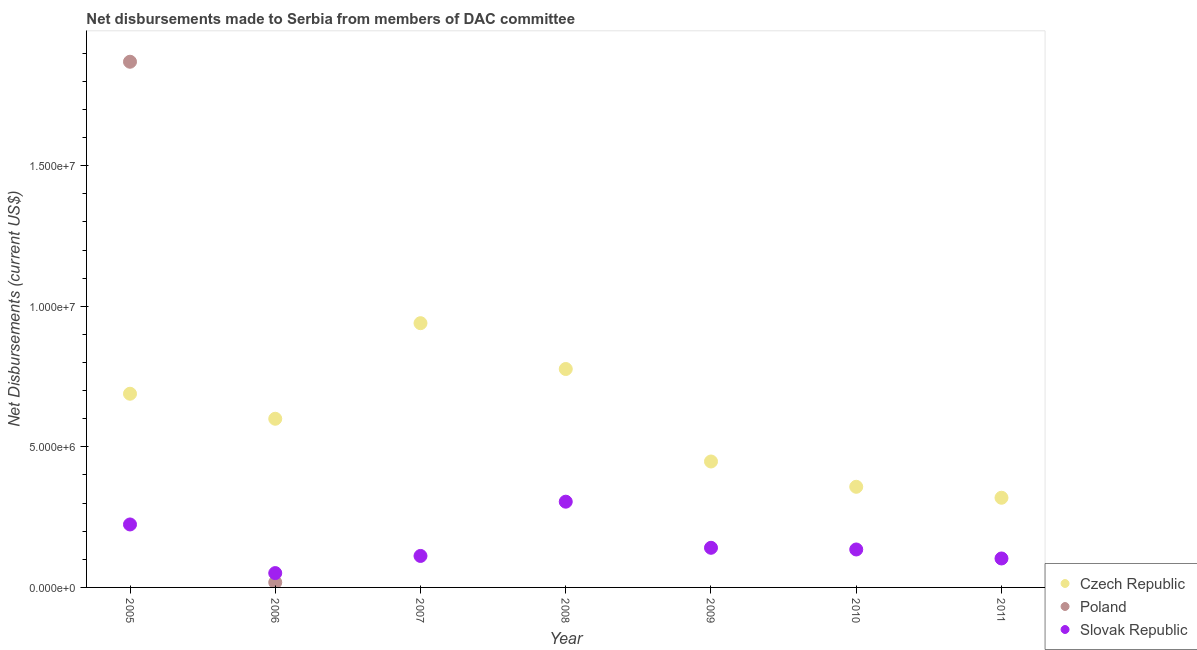How many different coloured dotlines are there?
Your response must be concise. 3. What is the net disbursements made by slovak republic in 2010?
Keep it short and to the point. 1.35e+06. Across all years, what is the maximum net disbursements made by slovak republic?
Provide a succinct answer. 3.05e+06. Across all years, what is the minimum net disbursements made by slovak republic?
Provide a succinct answer. 5.10e+05. In which year was the net disbursements made by poland maximum?
Provide a short and direct response. 2005. What is the total net disbursements made by czech republic in the graph?
Provide a short and direct response. 4.13e+07. What is the difference between the net disbursements made by czech republic in 2007 and that in 2010?
Offer a terse response. 5.82e+06. What is the difference between the net disbursements made by slovak republic in 2011 and the net disbursements made by czech republic in 2010?
Make the answer very short. -2.55e+06. What is the average net disbursements made by czech republic per year?
Give a very brief answer. 5.90e+06. In the year 2006, what is the difference between the net disbursements made by slovak republic and net disbursements made by czech republic?
Your answer should be very brief. -5.49e+06. What is the ratio of the net disbursements made by slovak republic in 2007 to that in 2010?
Give a very brief answer. 0.83. Is the net disbursements made by slovak republic in 2008 less than that in 2011?
Your answer should be very brief. No. What is the difference between the highest and the second highest net disbursements made by czech republic?
Offer a terse response. 1.63e+06. What is the difference between the highest and the lowest net disbursements made by poland?
Offer a terse response. 1.87e+07. Is it the case that in every year, the sum of the net disbursements made by czech republic and net disbursements made by poland is greater than the net disbursements made by slovak republic?
Make the answer very short. Yes. Does the net disbursements made by czech republic monotonically increase over the years?
Offer a very short reply. No. Is the net disbursements made by czech republic strictly greater than the net disbursements made by poland over the years?
Your response must be concise. No. Is the net disbursements made by slovak republic strictly less than the net disbursements made by poland over the years?
Keep it short and to the point. No. How many years are there in the graph?
Ensure brevity in your answer.  7. Are the values on the major ticks of Y-axis written in scientific E-notation?
Your answer should be very brief. Yes. Does the graph contain grids?
Make the answer very short. No. What is the title of the graph?
Make the answer very short. Net disbursements made to Serbia from members of DAC committee. Does "Ages 20-60" appear as one of the legend labels in the graph?
Keep it short and to the point. No. What is the label or title of the X-axis?
Provide a short and direct response. Year. What is the label or title of the Y-axis?
Provide a short and direct response. Net Disbursements (current US$). What is the Net Disbursements (current US$) in Czech Republic in 2005?
Ensure brevity in your answer.  6.89e+06. What is the Net Disbursements (current US$) in Poland in 2005?
Give a very brief answer. 1.87e+07. What is the Net Disbursements (current US$) of Slovak Republic in 2005?
Offer a terse response. 2.24e+06. What is the Net Disbursements (current US$) of Poland in 2006?
Give a very brief answer. 1.80e+05. What is the Net Disbursements (current US$) of Slovak Republic in 2006?
Keep it short and to the point. 5.10e+05. What is the Net Disbursements (current US$) of Czech Republic in 2007?
Make the answer very short. 9.40e+06. What is the Net Disbursements (current US$) of Slovak Republic in 2007?
Your answer should be compact. 1.12e+06. What is the Net Disbursements (current US$) in Czech Republic in 2008?
Give a very brief answer. 7.77e+06. What is the Net Disbursements (current US$) in Poland in 2008?
Make the answer very short. 0. What is the Net Disbursements (current US$) in Slovak Republic in 2008?
Give a very brief answer. 3.05e+06. What is the Net Disbursements (current US$) of Czech Republic in 2009?
Provide a short and direct response. 4.48e+06. What is the Net Disbursements (current US$) of Slovak Republic in 2009?
Ensure brevity in your answer.  1.41e+06. What is the Net Disbursements (current US$) of Czech Republic in 2010?
Offer a terse response. 3.58e+06. What is the Net Disbursements (current US$) of Poland in 2010?
Ensure brevity in your answer.  0. What is the Net Disbursements (current US$) of Slovak Republic in 2010?
Provide a succinct answer. 1.35e+06. What is the Net Disbursements (current US$) of Czech Republic in 2011?
Keep it short and to the point. 3.19e+06. What is the Net Disbursements (current US$) of Slovak Republic in 2011?
Offer a terse response. 1.03e+06. Across all years, what is the maximum Net Disbursements (current US$) of Czech Republic?
Ensure brevity in your answer.  9.40e+06. Across all years, what is the maximum Net Disbursements (current US$) of Poland?
Your answer should be compact. 1.87e+07. Across all years, what is the maximum Net Disbursements (current US$) of Slovak Republic?
Provide a short and direct response. 3.05e+06. Across all years, what is the minimum Net Disbursements (current US$) in Czech Republic?
Offer a very short reply. 3.19e+06. Across all years, what is the minimum Net Disbursements (current US$) of Poland?
Your response must be concise. 0. Across all years, what is the minimum Net Disbursements (current US$) in Slovak Republic?
Give a very brief answer. 5.10e+05. What is the total Net Disbursements (current US$) in Czech Republic in the graph?
Ensure brevity in your answer.  4.13e+07. What is the total Net Disbursements (current US$) in Poland in the graph?
Your answer should be very brief. 1.89e+07. What is the total Net Disbursements (current US$) in Slovak Republic in the graph?
Offer a very short reply. 1.07e+07. What is the difference between the Net Disbursements (current US$) of Czech Republic in 2005 and that in 2006?
Your response must be concise. 8.90e+05. What is the difference between the Net Disbursements (current US$) of Poland in 2005 and that in 2006?
Keep it short and to the point. 1.85e+07. What is the difference between the Net Disbursements (current US$) in Slovak Republic in 2005 and that in 2006?
Provide a succinct answer. 1.73e+06. What is the difference between the Net Disbursements (current US$) of Czech Republic in 2005 and that in 2007?
Keep it short and to the point. -2.51e+06. What is the difference between the Net Disbursements (current US$) in Slovak Republic in 2005 and that in 2007?
Your response must be concise. 1.12e+06. What is the difference between the Net Disbursements (current US$) in Czech Republic in 2005 and that in 2008?
Keep it short and to the point. -8.80e+05. What is the difference between the Net Disbursements (current US$) in Slovak Republic in 2005 and that in 2008?
Offer a very short reply. -8.10e+05. What is the difference between the Net Disbursements (current US$) of Czech Republic in 2005 and that in 2009?
Ensure brevity in your answer.  2.41e+06. What is the difference between the Net Disbursements (current US$) of Slovak Republic in 2005 and that in 2009?
Provide a succinct answer. 8.30e+05. What is the difference between the Net Disbursements (current US$) in Czech Republic in 2005 and that in 2010?
Your response must be concise. 3.31e+06. What is the difference between the Net Disbursements (current US$) of Slovak Republic in 2005 and that in 2010?
Offer a very short reply. 8.90e+05. What is the difference between the Net Disbursements (current US$) in Czech Republic in 2005 and that in 2011?
Offer a very short reply. 3.70e+06. What is the difference between the Net Disbursements (current US$) of Slovak Republic in 2005 and that in 2011?
Offer a terse response. 1.21e+06. What is the difference between the Net Disbursements (current US$) in Czech Republic in 2006 and that in 2007?
Keep it short and to the point. -3.40e+06. What is the difference between the Net Disbursements (current US$) in Slovak Republic in 2006 and that in 2007?
Your answer should be compact. -6.10e+05. What is the difference between the Net Disbursements (current US$) of Czech Republic in 2006 and that in 2008?
Your response must be concise. -1.77e+06. What is the difference between the Net Disbursements (current US$) of Slovak Republic in 2006 and that in 2008?
Your answer should be very brief. -2.54e+06. What is the difference between the Net Disbursements (current US$) of Czech Republic in 2006 and that in 2009?
Give a very brief answer. 1.52e+06. What is the difference between the Net Disbursements (current US$) in Slovak Republic in 2006 and that in 2009?
Offer a terse response. -9.00e+05. What is the difference between the Net Disbursements (current US$) in Czech Republic in 2006 and that in 2010?
Provide a succinct answer. 2.42e+06. What is the difference between the Net Disbursements (current US$) of Slovak Republic in 2006 and that in 2010?
Your answer should be compact. -8.40e+05. What is the difference between the Net Disbursements (current US$) in Czech Republic in 2006 and that in 2011?
Offer a terse response. 2.81e+06. What is the difference between the Net Disbursements (current US$) of Slovak Republic in 2006 and that in 2011?
Make the answer very short. -5.20e+05. What is the difference between the Net Disbursements (current US$) of Czech Republic in 2007 and that in 2008?
Keep it short and to the point. 1.63e+06. What is the difference between the Net Disbursements (current US$) in Slovak Republic in 2007 and that in 2008?
Ensure brevity in your answer.  -1.93e+06. What is the difference between the Net Disbursements (current US$) in Czech Republic in 2007 and that in 2009?
Offer a very short reply. 4.92e+06. What is the difference between the Net Disbursements (current US$) of Czech Republic in 2007 and that in 2010?
Keep it short and to the point. 5.82e+06. What is the difference between the Net Disbursements (current US$) of Czech Republic in 2007 and that in 2011?
Ensure brevity in your answer.  6.21e+06. What is the difference between the Net Disbursements (current US$) in Slovak Republic in 2007 and that in 2011?
Your answer should be very brief. 9.00e+04. What is the difference between the Net Disbursements (current US$) of Czech Republic in 2008 and that in 2009?
Your answer should be compact. 3.29e+06. What is the difference between the Net Disbursements (current US$) in Slovak Republic in 2008 and that in 2009?
Provide a succinct answer. 1.64e+06. What is the difference between the Net Disbursements (current US$) in Czech Republic in 2008 and that in 2010?
Your answer should be compact. 4.19e+06. What is the difference between the Net Disbursements (current US$) in Slovak Republic in 2008 and that in 2010?
Provide a succinct answer. 1.70e+06. What is the difference between the Net Disbursements (current US$) in Czech Republic in 2008 and that in 2011?
Your answer should be very brief. 4.58e+06. What is the difference between the Net Disbursements (current US$) of Slovak Republic in 2008 and that in 2011?
Your response must be concise. 2.02e+06. What is the difference between the Net Disbursements (current US$) of Czech Republic in 2009 and that in 2010?
Provide a short and direct response. 9.00e+05. What is the difference between the Net Disbursements (current US$) of Czech Republic in 2009 and that in 2011?
Offer a terse response. 1.29e+06. What is the difference between the Net Disbursements (current US$) in Slovak Republic in 2010 and that in 2011?
Your response must be concise. 3.20e+05. What is the difference between the Net Disbursements (current US$) in Czech Republic in 2005 and the Net Disbursements (current US$) in Poland in 2006?
Offer a terse response. 6.71e+06. What is the difference between the Net Disbursements (current US$) of Czech Republic in 2005 and the Net Disbursements (current US$) of Slovak Republic in 2006?
Your response must be concise. 6.38e+06. What is the difference between the Net Disbursements (current US$) of Poland in 2005 and the Net Disbursements (current US$) of Slovak Republic in 2006?
Keep it short and to the point. 1.82e+07. What is the difference between the Net Disbursements (current US$) of Czech Republic in 2005 and the Net Disbursements (current US$) of Slovak Republic in 2007?
Offer a terse response. 5.77e+06. What is the difference between the Net Disbursements (current US$) in Poland in 2005 and the Net Disbursements (current US$) in Slovak Republic in 2007?
Ensure brevity in your answer.  1.76e+07. What is the difference between the Net Disbursements (current US$) in Czech Republic in 2005 and the Net Disbursements (current US$) in Slovak Republic in 2008?
Your response must be concise. 3.84e+06. What is the difference between the Net Disbursements (current US$) in Poland in 2005 and the Net Disbursements (current US$) in Slovak Republic in 2008?
Offer a terse response. 1.56e+07. What is the difference between the Net Disbursements (current US$) of Czech Republic in 2005 and the Net Disbursements (current US$) of Slovak Republic in 2009?
Give a very brief answer. 5.48e+06. What is the difference between the Net Disbursements (current US$) of Poland in 2005 and the Net Disbursements (current US$) of Slovak Republic in 2009?
Ensure brevity in your answer.  1.73e+07. What is the difference between the Net Disbursements (current US$) of Czech Republic in 2005 and the Net Disbursements (current US$) of Slovak Republic in 2010?
Ensure brevity in your answer.  5.54e+06. What is the difference between the Net Disbursements (current US$) of Poland in 2005 and the Net Disbursements (current US$) of Slovak Republic in 2010?
Provide a short and direct response. 1.74e+07. What is the difference between the Net Disbursements (current US$) in Czech Republic in 2005 and the Net Disbursements (current US$) in Slovak Republic in 2011?
Keep it short and to the point. 5.86e+06. What is the difference between the Net Disbursements (current US$) in Poland in 2005 and the Net Disbursements (current US$) in Slovak Republic in 2011?
Ensure brevity in your answer.  1.77e+07. What is the difference between the Net Disbursements (current US$) of Czech Republic in 2006 and the Net Disbursements (current US$) of Slovak Republic in 2007?
Your response must be concise. 4.88e+06. What is the difference between the Net Disbursements (current US$) of Poland in 2006 and the Net Disbursements (current US$) of Slovak Republic in 2007?
Your answer should be very brief. -9.40e+05. What is the difference between the Net Disbursements (current US$) of Czech Republic in 2006 and the Net Disbursements (current US$) of Slovak Republic in 2008?
Your answer should be very brief. 2.95e+06. What is the difference between the Net Disbursements (current US$) in Poland in 2006 and the Net Disbursements (current US$) in Slovak Republic in 2008?
Offer a terse response. -2.87e+06. What is the difference between the Net Disbursements (current US$) in Czech Republic in 2006 and the Net Disbursements (current US$) in Slovak Republic in 2009?
Give a very brief answer. 4.59e+06. What is the difference between the Net Disbursements (current US$) in Poland in 2006 and the Net Disbursements (current US$) in Slovak Republic in 2009?
Offer a very short reply. -1.23e+06. What is the difference between the Net Disbursements (current US$) of Czech Republic in 2006 and the Net Disbursements (current US$) of Slovak Republic in 2010?
Offer a very short reply. 4.65e+06. What is the difference between the Net Disbursements (current US$) of Poland in 2006 and the Net Disbursements (current US$) of Slovak Republic in 2010?
Provide a short and direct response. -1.17e+06. What is the difference between the Net Disbursements (current US$) of Czech Republic in 2006 and the Net Disbursements (current US$) of Slovak Republic in 2011?
Give a very brief answer. 4.97e+06. What is the difference between the Net Disbursements (current US$) in Poland in 2006 and the Net Disbursements (current US$) in Slovak Republic in 2011?
Offer a very short reply. -8.50e+05. What is the difference between the Net Disbursements (current US$) of Czech Republic in 2007 and the Net Disbursements (current US$) of Slovak Republic in 2008?
Provide a succinct answer. 6.35e+06. What is the difference between the Net Disbursements (current US$) in Czech Republic in 2007 and the Net Disbursements (current US$) in Slovak Republic in 2009?
Your answer should be very brief. 7.99e+06. What is the difference between the Net Disbursements (current US$) in Czech Republic in 2007 and the Net Disbursements (current US$) in Slovak Republic in 2010?
Your answer should be very brief. 8.05e+06. What is the difference between the Net Disbursements (current US$) of Czech Republic in 2007 and the Net Disbursements (current US$) of Slovak Republic in 2011?
Make the answer very short. 8.37e+06. What is the difference between the Net Disbursements (current US$) of Czech Republic in 2008 and the Net Disbursements (current US$) of Slovak Republic in 2009?
Provide a succinct answer. 6.36e+06. What is the difference between the Net Disbursements (current US$) in Czech Republic in 2008 and the Net Disbursements (current US$) in Slovak Republic in 2010?
Offer a very short reply. 6.42e+06. What is the difference between the Net Disbursements (current US$) in Czech Republic in 2008 and the Net Disbursements (current US$) in Slovak Republic in 2011?
Offer a terse response. 6.74e+06. What is the difference between the Net Disbursements (current US$) in Czech Republic in 2009 and the Net Disbursements (current US$) in Slovak Republic in 2010?
Your response must be concise. 3.13e+06. What is the difference between the Net Disbursements (current US$) of Czech Republic in 2009 and the Net Disbursements (current US$) of Slovak Republic in 2011?
Offer a terse response. 3.45e+06. What is the difference between the Net Disbursements (current US$) of Czech Republic in 2010 and the Net Disbursements (current US$) of Slovak Republic in 2011?
Provide a short and direct response. 2.55e+06. What is the average Net Disbursements (current US$) in Czech Republic per year?
Your response must be concise. 5.90e+06. What is the average Net Disbursements (current US$) in Poland per year?
Your answer should be compact. 2.70e+06. What is the average Net Disbursements (current US$) of Slovak Republic per year?
Provide a succinct answer. 1.53e+06. In the year 2005, what is the difference between the Net Disbursements (current US$) of Czech Republic and Net Disbursements (current US$) of Poland?
Your answer should be very brief. -1.18e+07. In the year 2005, what is the difference between the Net Disbursements (current US$) of Czech Republic and Net Disbursements (current US$) of Slovak Republic?
Your answer should be very brief. 4.65e+06. In the year 2005, what is the difference between the Net Disbursements (current US$) of Poland and Net Disbursements (current US$) of Slovak Republic?
Make the answer very short. 1.65e+07. In the year 2006, what is the difference between the Net Disbursements (current US$) in Czech Republic and Net Disbursements (current US$) in Poland?
Keep it short and to the point. 5.82e+06. In the year 2006, what is the difference between the Net Disbursements (current US$) in Czech Republic and Net Disbursements (current US$) in Slovak Republic?
Ensure brevity in your answer.  5.49e+06. In the year 2006, what is the difference between the Net Disbursements (current US$) in Poland and Net Disbursements (current US$) in Slovak Republic?
Make the answer very short. -3.30e+05. In the year 2007, what is the difference between the Net Disbursements (current US$) in Czech Republic and Net Disbursements (current US$) in Slovak Republic?
Give a very brief answer. 8.28e+06. In the year 2008, what is the difference between the Net Disbursements (current US$) in Czech Republic and Net Disbursements (current US$) in Slovak Republic?
Your response must be concise. 4.72e+06. In the year 2009, what is the difference between the Net Disbursements (current US$) in Czech Republic and Net Disbursements (current US$) in Slovak Republic?
Make the answer very short. 3.07e+06. In the year 2010, what is the difference between the Net Disbursements (current US$) in Czech Republic and Net Disbursements (current US$) in Slovak Republic?
Offer a very short reply. 2.23e+06. In the year 2011, what is the difference between the Net Disbursements (current US$) in Czech Republic and Net Disbursements (current US$) in Slovak Republic?
Ensure brevity in your answer.  2.16e+06. What is the ratio of the Net Disbursements (current US$) of Czech Republic in 2005 to that in 2006?
Offer a terse response. 1.15. What is the ratio of the Net Disbursements (current US$) of Poland in 2005 to that in 2006?
Offer a very short reply. 103.89. What is the ratio of the Net Disbursements (current US$) in Slovak Republic in 2005 to that in 2006?
Your answer should be very brief. 4.39. What is the ratio of the Net Disbursements (current US$) of Czech Republic in 2005 to that in 2007?
Your answer should be very brief. 0.73. What is the ratio of the Net Disbursements (current US$) of Slovak Republic in 2005 to that in 2007?
Your response must be concise. 2. What is the ratio of the Net Disbursements (current US$) in Czech Republic in 2005 to that in 2008?
Your answer should be very brief. 0.89. What is the ratio of the Net Disbursements (current US$) of Slovak Republic in 2005 to that in 2008?
Your response must be concise. 0.73. What is the ratio of the Net Disbursements (current US$) in Czech Republic in 2005 to that in 2009?
Make the answer very short. 1.54. What is the ratio of the Net Disbursements (current US$) in Slovak Republic in 2005 to that in 2009?
Provide a succinct answer. 1.59. What is the ratio of the Net Disbursements (current US$) in Czech Republic in 2005 to that in 2010?
Make the answer very short. 1.92. What is the ratio of the Net Disbursements (current US$) of Slovak Republic in 2005 to that in 2010?
Your answer should be very brief. 1.66. What is the ratio of the Net Disbursements (current US$) in Czech Republic in 2005 to that in 2011?
Your answer should be very brief. 2.16. What is the ratio of the Net Disbursements (current US$) of Slovak Republic in 2005 to that in 2011?
Offer a terse response. 2.17. What is the ratio of the Net Disbursements (current US$) of Czech Republic in 2006 to that in 2007?
Offer a terse response. 0.64. What is the ratio of the Net Disbursements (current US$) of Slovak Republic in 2006 to that in 2007?
Offer a very short reply. 0.46. What is the ratio of the Net Disbursements (current US$) of Czech Republic in 2006 to that in 2008?
Provide a succinct answer. 0.77. What is the ratio of the Net Disbursements (current US$) of Slovak Republic in 2006 to that in 2008?
Your answer should be compact. 0.17. What is the ratio of the Net Disbursements (current US$) of Czech Republic in 2006 to that in 2009?
Give a very brief answer. 1.34. What is the ratio of the Net Disbursements (current US$) of Slovak Republic in 2006 to that in 2009?
Provide a succinct answer. 0.36. What is the ratio of the Net Disbursements (current US$) in Czech Republic in 2006 to that in 2010?
Your answer should be compact. 1.68. What is the ratio of the Net Disbursements (current US$) in Slovak Republic in 2006 to that in 2010?
Keep it short and to the point. 0.38. What is the ratio of the Net Disbursements (current US$) in Czech Republic in 2006 to that in 2011?
Provide a short and direct response. 1.88. What is the ratio of the Net Disbursements (current US$) in Slovak Republic in 2006 to that in 2011?
Give a very brief answer. 0.5. What is the ratio of the Net Disbursements (current US$) of Czech Republic in 2007 to that in 2008?
Give a very brief answer. 1.21. What is the ratio of the Net Disbursements (current US$) of Slovak Republic in 2007 to that in 2008?
Provide a short and direct response. 0.37. What is the ratio of the Net Disbursements (current US$) in Czech Republic in 2007 to that in 2009?
Make the answer very short. 2.1. What is the ratio of the Net Disbursements (current US$) in Slovak Republic in 2007 to that in 2009?
Your response must be concise. 0.79. What is the ratio of the Net Disbursements (current US$) in Czech Republic in 2007 to that in 2010?
Make the answer very short. 2.63. What is the ratio of the Net Disbursements (current US$) in Slovak Republic in 2007 to that in 2010?
Make the answer very short. 0.83. What is the ratio of the Net Disbursements (current US$) of Czech Republic in 2007 to that in 2011?
Provide a short and direct response. 2.95. What is the ratio of the Net Disbursements (current US$) of Slovak Republic in 2007 to that in 2011?
Give a very brief answer. 1.09. What is the ratio of the Net Disbursements (current US$) of Czech Republic in 2008 to that in 2009?
Offer a terse response. 1.73. What is the ratio of the Net Disbursements (current US$) in Slovak Republic in 2008 to that in 2009?
Keep it short and to the point. 2.16. What is the ratio of the Net Disbursements (current US$) of Czech Republic in 2008 to that in 2010?
Give a very brief answer. 2.17. What is the ratio of the Net Disbursements (current US$) in Slovak Republic in 2008 to that in 2010?
Ensure brevity in your answer.  2.26. What is the ratio of the Net Disbursements (current US$) of Czech Republic in 2008 to that in 2011?
Your response must be concise. 2.44. What is the ratio of the Net Disbursements (current US$) in Slovak Republic in 2008 to that in 2011?
Keep it short and to the point. 2.96. What is the ratio of the Net Disbursements (current US$) of Czech Republic in 2009 to that in 2010?
Offer a very short reply. 1.25. What is the ratio of the Net Disbursements (current US$) of Slovak Republic in 2009 to that in 2010?
Give a very brief answer. 1.04. What is the ratio of the Net Disbursements (current US$) of Czech Republic in 2009 to that in 2011?
Make the answer very short. 1.4. What is the ratio of the Net Disbursements (current US$) in Slovak Republic in 2009 to that in 2011?
Your answer should be compact. 1.37. What is the ratio of the Net Disbursements (current US$) of Czech Republic in 2010 to that in 2011?
Offer a terse response. 1.12. What is the ratio of the Net Disbursements (current US$) in Slovak Republic in 2010 to that in 2011?
Your answer should be compact. 1.31. What is the difference between the highest and the second highest Net Disbursements (current US$) of Czech Republic?
Provide a succinct answer. 1.63e+06. What is the difference between the highest and the second highest Net Disbursements (current US$) of Slovak Republic?
Offer a terse response. 8.10e+05. What is the difference between the highest and the lowest Net Disbursements (current US$) of Czech Republic?
Your answer should be very brief. 6.21e+06. What is the difference between the highest and the lowest Net Disbursements (current US$) of Poland?
Make the answer very short. 1.87e+07. What is the difference between the highest and the lowest Net Disbursements (current US$) of Slovak Republic?
Give a very brief answer. 2.54e+06. 